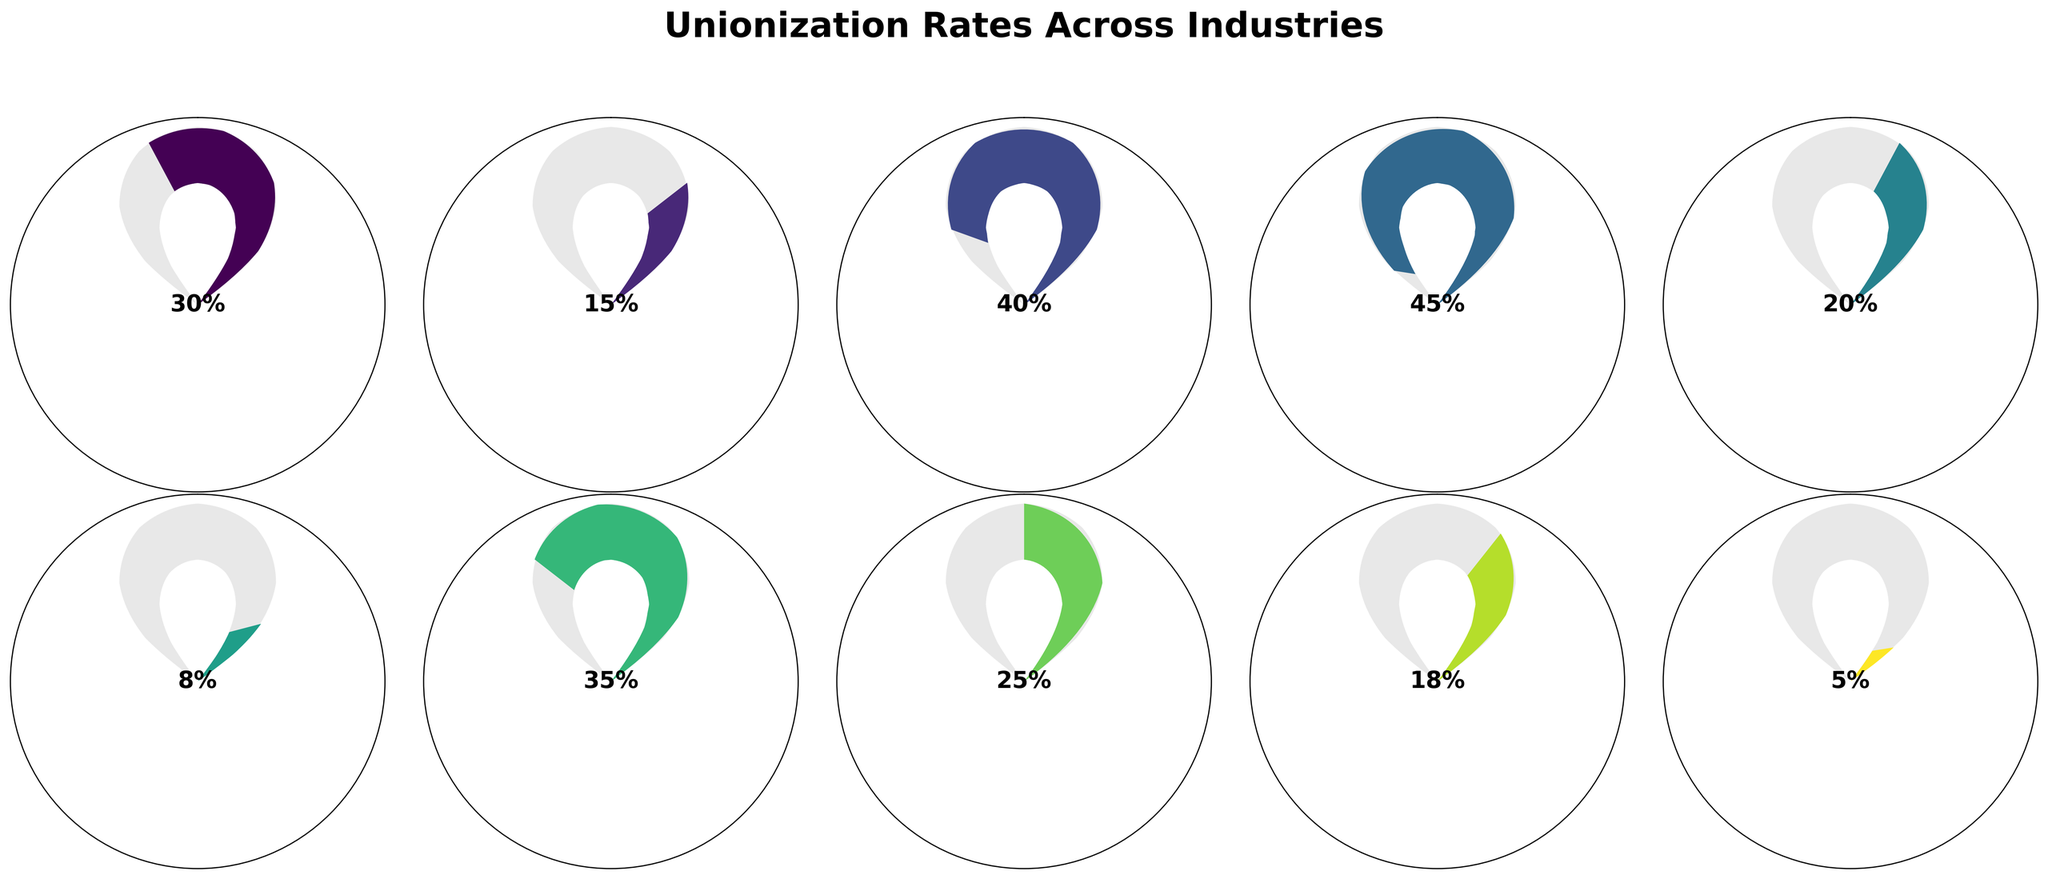How many industries have a unionization rate above 30%? From the figure, identify all the industries with unionization rates higher than 30%. There are four industries: Education (40%), Transportation (45%), Public Sector (35%), and Manufacturing (30%).
Answer: 4 Which industry has the lowest unionization rate and what is the rate? Look for the gauge with the smallest fill. The Agriculture industry has the lowest unionization rate, which is 5%.
Answer: Agriculture, 5% What is the average unionization rate across all provided industries? Sum the unionization rates of all industries (30+15+40+45+20+8+35+25+18+5) and divide by the total number of industries (10). The sum is 241, and the average is 241/10.
Answer: 24.1 Which two industries have the closest unionization rates, and what are their rates? Compare the rates visually to find the two that are closest. Telecommunications (18%) and Healthcare (15%) have the closest unionization rates.
Answer: Telecommunications and Healthcare, 18% and 15% What's the difference in unionization rate between the industry with the highest rate and the industry with the lowest rate? Identify the highest rate (Transportation, 45%) and the lowest rate (Agriculture, 5%) and calculate the difference (45 - 5).
Answer: 40 If the unionization rate of Construction increased by 10%, how would it compare to Healthcare? Add 10% to Construction’s rate (20 + 10 = 30) and compare it with Healthcare’s rate (15%). Construction’s new rate would be higher.
Answer: Higher Which industries have unionization rates below 20%? Identify the gauges with labels indicating rates below 20%. These are Healthcare (15%), Retail (8%), Telecommunications (18%), and Agriculture (5%).
Answer: 4 What is the median unionization rate among all industries? Arrange the rates in numerical order: [5, 8, 15, 18, 20, 25, 30, 35, 40, 45]. The median is the middle value of these rates.
Answer: 22.5 Which industry’s unionization rate is exactly half of Education’s rate? Identify Education’s rate (40%) and find the industry with half of that rate (40 / 2 = 20). Construction has a 20% unionization rate.
Answer: Construction Which industries have unionization rates higher than the average rate? Calculate the average rate (24.1%). Identify industries with rates higher than this: Manufacturing (30%), Education (40%), Transportation (45%), Public Sector (35%), and Mining (25%).
Answer: 5 